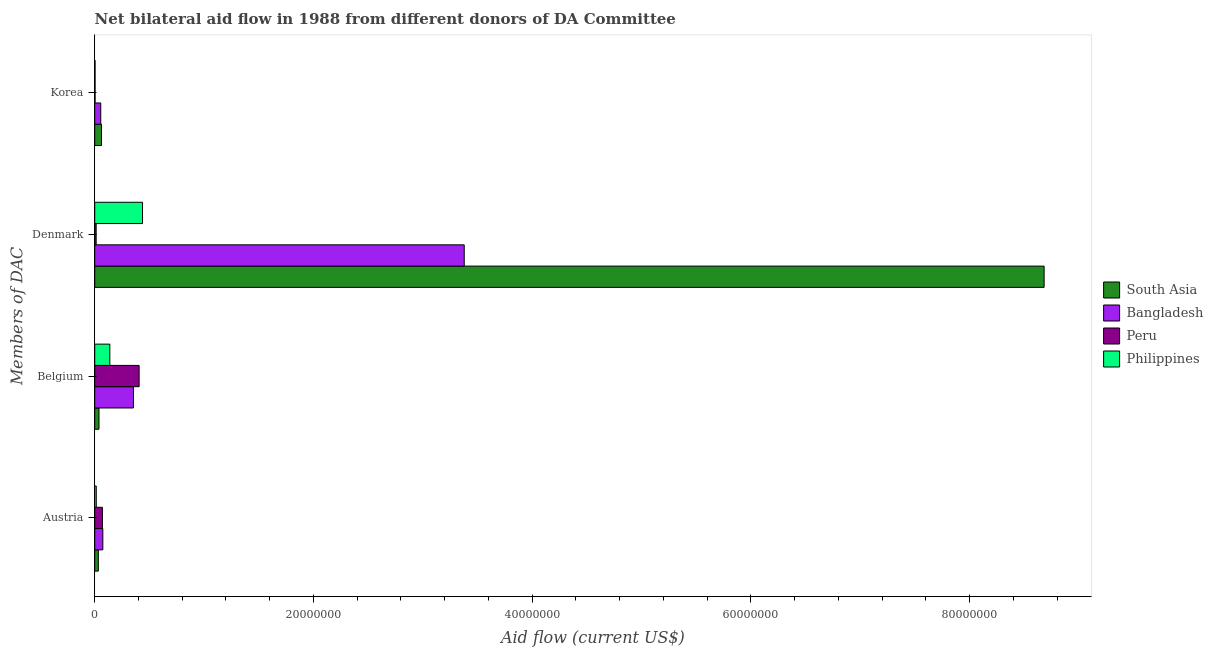Are the number of bars on each tick of the Y-axis equal?
Make the answer very short. Yes. How many bars are there on the 2nd tick from the bottom?
Ensure brevity in your answer.  4. What is the label of the 2nd group of bars from the top?
Make the answer very short. Denmark. What is the amount of aid given by korea in Philippines?
Keep it short and to the point. 3.00e+04. Across all countries, what is the maximum amount of aid given by korea?
Offer a terse response. 6.20e+05. Across all countries, what is the minimum amount of aid given by austria?
Offer a terse response. 1.40e+05. In which country was the amount of aid given by belgium maximum?
Offer a terse response. Peru. What is the total amount of aid given by belgium in the graph?
Your answer should be compact. 9.37e+06. What is the difference between the amount of aid given by austria in Bangladesh and that in Peru?
Make the answer very short. 4.00e+04. What is the difference between the amount of aid given by korea in South Asia and the amount of aid given by denmark in Philippines?
Provide a short and direct response. -3.75e+06. What is the average amount of aid given by austria per country?
Give a very brief answer. 4.78e+05. What is the difference between the amount of aid given by belgium and amount of aid given by denmark in Philippines?
Your answer should be compact. -2.99e+06. In how many countries, is the amount of aid given by austria greater than 36000000 US$?
Give a very brief answer. 0. What is the ratio of the amount of aid given by denmark in Peru to that in Philippines?
Give a very brief answer. 0.03. What is the difference between the highest and the second highest amount of aid given by belgium?
Offer a terse response. 5.20e+05. What is the difference between the highest and the lowest amount of aid given by korea?
Provide a short and direct response. 5.90e+05. In how many countries, is the amount of aid given by austria greater than the average amount of aid given by austria taken over all countries?
Keep it short and to the point. 2. What does the 3rd bar from the bottom in Denmark represents?
Your response must be concise. Peru. Are all the bars in the graph horizontal?
Keep it short and to the point. Yes. What is the difference between two consecutive major ticks on the X-axis?
Provide a short and direct response. 2.00e+07. Does the graph contain grids?
Give a very brief answer. No. Where does the legend appear in the graph?
Ensure brevity in your answer.  Center right. What is the title of the graph?
Your response must be concise. Net bilateral aid flow in 1988 from different donors of DA Committee. What is the label or title of the Y-axis?
Provide a short and direct response. Members of DAC. What is the Aid flow (current US$) in Bangladesh in Austria?
Keep it short and to the point. 7.40e+05. What is the Aid flow (current US$) of South Asia in Belgium?
Your answer should be very brief. 3.90e+05. What is the Aid flow (current US$) in Bangladesh in Belgium?
Offer a very short reply. 3.54e+06. What is the Aid flow (current US$) of Peru in Belgium?
Offer a terse response. 4.06e+06. What is the Aid flow (current US$) of Philippines in Belgium?
Keep it short and to the point. 1.38e+06. What is the Aid flow (current US$) in South Asia in Denmark?
Make the answer very short. 8.68e+07. What is the Aid flow (current US$) in Bangladesh in Denmark?
Keep it short and to the point. 3.38e+07. What is the Aid flow (current US$) of Peru in Denmark?
Give a very brief answer. 1.30e+05. What is the Aid flow (current US$) in Philippines in Denmark?
Provide a short and direct response. 4.37e+06. What is the Aid flow (current US$) of South Asia in Korea?
Keep it short and to the point. 6.20e+05. What is the Aid flow (current US$) in Bangladesh in Korea?
Provide a succinct answer. 5.50e+05. What is the Aid flow (current US$) in Peru in Korea?
Your response must be concise. 3.00e+04. What is the Aid flow (current US$) in Philippines in Korea?
Offer a terse response. 3.00e+04. Across all Members of DAC, what is the maximum Aid flow (current US$) of South Asia?
Provide a succinct answer. 8.68e+07. Across all Members of DAC, what is the maximum Aid flow (current US$) in Bangladesh?
Offer a very short reply. 3.38e+07. Across all Members of DAC, what is the maximum Aid flow (current US$) in Peru?
Give a very brief answer. 4.06e+06. Across all Members of DAC, what is the maximum Aid flow (current US$) in Philippines?
Offer a very short reply. 4.37e+06. Across all Members of DAC, what is the minimum Aid flow (current US$) in Bangladesh?
Your answer should be compact. 5.50e+05. Across all Members of DAC, what is the minimum Aid flow (current US$) of Peru?
Provide a short and direct response. 3.00e+04. What is the total Aid flow (current US$) of South Asia in the graph?
Your response must be concise. 8.82e+07. What is the total Aid flow (current US$) of Bangladesh in the graph?
Your answer should be very brief. 3.86e+07. What is the total Aid flow (current US$) of Peru in the graph?
Keep it short and to the point. 4.92e+06. What is the total Aid flow (current US$) of Philippines in the graph?
Provide a succinct answer. 5.92e+06. What is the difference between the Aid flow (current US$) in South Asia in Austria and that in Belgium?
Provide a short and direct response. -6.00e+04. What is the difference between the Aid flow (current US$) of Bangladesh in Austria and that in Belgium?
Your response must be concise. -2.80e+06. What is the difference between the Aid flow (current US$) of Peru in Austria and that in Belgium?
Keep it short and to the point. -3.36e+06. What is the difference between the Aid flow (current US$) of Philippines in Austria and that in Belgium?
Provide a short and direct response. -1.24e+06. What is the difference between the Aid flow (current US$) of South Asia in Austria and that in Denmark?
Provide a succinct answer. -8.65e+07. What is the difference between the Aid flow (current US$) of Bangladesh in Austria and that in Denmark?
Your answer should be compact. -3.30e+07. What is the difference between the Aid flow (current US$) of Peru in Austria and that in Denmark?
Your answer should be compact. 5.70e+05. What is the difference between the Aid flow (current US$) in Philippines in Austria and that in Denmark?
Make the answer very short. -4.23e+06. What is the difference between the Aid flow (current US$) in Bangladesh in Austria and that in Korea?
Your answer should be compact. 1.90e+05. What is the difference between the Aid flow (current US$) of Peru in Austria and that in Korea?
Provide a succinct answer. 6.70e+05. What is the difference between the Aid flow (current US$) of South Asia in Belgium and that in Denmark?
Offer a terse response. -8.64e+07. What is the difference between the Aid flow (current US$) in Bangladesh in Belgium and that in Denmark?
Offer a terse response. -3.02e+07. What is the difference between the Aid flow (current US$) in Peru in Belgium and that in Denmark?
Ensure brevity in your answer.  3.93e+06. What is the difference between the Aid flow (current US$) of Philippines in Belgium and that in Denmark?
Offer a very short reply. -2.99e+06. What is the difference between the Aid flow (current US$) of South Asia in Belgium and that in Korea?
Give a very brief answer. -2.30e+05. What is the difference between the Aid flow (current US$) of Bangladesh in Belgium and that in Korea?
Offer a terse response. 2.99e+06. What is the difference between the Aid flow (current US$) of Peru in Belgium and that in Korea?
Your answer should be compact. 4.03e+06. What is the difference between the Aid flow (current US$) in Philippines in Belgium and that in Korea?
Make the answer very short. 1.35e+06. What is the difference between the Aid flow (current US$) of South Asia in Denmark and that in Korea?
Your answer should be very brief. 8.62e+07. What is the difference between the Aid flow (current US$) of Bangladesh in Denmark and that in Korea?
Ensure brevity in your answer.  3.32e+07. What is the difference between the Aid flow (current US$) in Philippines in Denmark and that in Korea?
Provide a succinct answer. 4.34e+06. What is the difference between the Aid flow (current US$) of South Asia in Austria and the Aid flow (current US$) of Bangladesh in Belgium?
Your answer should be very brief. -3.21e+06. What is the difference between the Aid flow (current US$) in South Asia in Austria and the Aid flow (current US$) in Peru in Belgium?
Provide a short and direct response. -3.73e+06. What is the difference between the Aid flow (current US$) in South Asia in Austria and the Aid flow (current US$) in Philippines in Belgium?
Make the answer very short. -1.05e+06. What is the difference between the Aid flow (current US$) in Bangladesh in Austria and the Aid flow (current US$) in Peru in Belgium?
Your answer should be compact. -3.32e+06. What is the difference between the Aid flow (current US$) in Bangladesh in Austria and the Aid flow (current US$) in Philippines in Belgium?
Provide a succinct answer. -6.40e+05. What is the difference between the Aid flow (current US$) in Peru in Austria and the Aid flow (current US$) in Philippines in Belgium?
Offer a terse response. -6.80e+05. What is the difference between the Aid flow (current US$) of South Asia in Austria and the Aid flow (current US$) of Bangladesh in Denmark?
Keep it short and to the point. -3.35e+07. What is the difference between the Aid flow (current US$) in South Asia in Austria and the Aid flow (current US$) in Peru in Denmark?
Offer a very short reply. 2.00e+05. What is the difference between the Aid flow (current US$) of South Asia in Austria and the Aid flow (current US$) of Philippines in Denmark?
Offer a very short reply. -4.04e+06. What is the difference between the Aid flow (current US$) in Bangladesh in Austria and the Aid flow (current US$) in Philippines in Denmark?
Offer a terse response. -3.63e+06. What is the difference between the Aid flow (current US$) in Peru in Austria and the Aid flow (current US$) in Philippines in Denmark?
Your response must be concise. -3.67e+06. What is the difference between the Aid flow (current US$) in South Asia in Austria and the Aid flow (current US$) in Bangladesh in Korea?
Offer a very short reply. -2.20e+05. What is the difference between the Aid flow (current US$) of South Asia in Austria and the Aid flow (current US$) of Peru in Korea?
Your answer should be compact. 3.00e+05. What is the difference between the Aid flow (current US$) in Bangladesh in Austria and the Aid flow (current US$) in Peru in Korea?
Offer a terse response. 7.10e+05. What is the difference between the Aid flow (current US$) in Bangladesh in Austria and the Aid flow (current US$) in Philippines in Korea?
Provide a short and direct response. 7.10e+05. What is the difference between the Aid flow (current US$) of Peru in Austria and the Aid flow (current US$) of Philippines in Korea?
Provide a short and direct response. 6.70e+05. What is the difference between the Aid flow (current US$) in South Asia in Belgium and the Aid flow (current US$) in Bangladesh in Denmark?
Make the answer very short. -3.34e+07. What is the difference between the Aid flow (current US$) in South Asia in Belgium and the Aid flow (current US$) in Peru in Denmark?
Your response must be concise. 2.60e+05. What is the difference between the Aid flow (current US$) in South Asia in Belgium and the Aid flow (current US$) in Philippines in Denmark?
Provide a short and direct response. -3.98e+06. What is the difference between the Aid flow (current US$) in Bangladesh in Belgium and the Aid flow (current US$) in Peru in Denmark?
Offer a very short reply. 3.41e+06. What is the difference between the Aid flow (current US$) of Bangladesh in Belgium and the Aid flow (current US$) of Philippines in Denmark?
Make the answer very short. -8.30e+05. What is the difference between the Aid flow (current US$) of Peru in Belgium and the Aid flow (current US$) of Philippines in Denmark?
Provide a short and direct response. -3.10e+05. What is the difference between the Aid flow (current US$) of South Asia in Belgium and the Aid flow (current US$) of Bangladesh in Korea?
Offer a terse response. -1.60e+05. What is the difference between the Aid flow (current US$) in South Asia in Belgium and the Aid flow (current US$) in Peru in Korea?
Offer a terse response. 3.60e+05. What is the difference between the Aid flow (current US$) of South Asia in Belgium and the Aid flow (current US$) of Philippines in Korea?
Your response must be concise. 3.60e+05. What is the difference between the Aid flow (current US$) of Bangladesh in Belgium and the Aid flow (current US$) of Peru in Korea?
Keep it short and to the point. 3.51e+06. What is the difference between the Aid flow (current US$) in Bangladesh in Belgium and the Aid flow (current US$) in Philippines in Korea?
Your response must be concise. 3.51e+06. What is the difference between the Aid flow (current US$) of Peru in Belgium and the Aid flow (current US$) of Philippines in Korea?
Your answer should be very brief. 4.03e+06. What is the difference between the Aid flow (current US$) in South Asia in Denmark and the Aid flow (current US$) in Bangladesh in Korea?
Offer a terse response. 8.63e+07. What is the difference between the Aid flow (current US$) in South Asia in Denmark and the Aid flow (current US$) in Peru in Korea?
Offer a terse response. 8.68e+07. What is the difference between the Aid flow (current US$) in South Asia in Denmark and the Aid flow (current US$) in Philippines in Korea?
Make the answer very short. 8.68e+07. What is the difference between the Aid flow (current US$) of Bangladesh in Denmark and the Aid flow (current US$) of Peru in Korea?
Your response must be concise. 3.38e+07. What is the difference between the Aid flow (current US$) in Bangladesh in Denmark and the Aid flow (current US$) in Philippines in Korea?
Your answer should be very brief. 3.38e+07. What is the difference between the Aid flow (current US$) of Peru in Denmark and the Aid flow (current US$) of Philippines in Korea?
Keep it short and to the point. 1.00e+05. What is the average Aid flow (current US$) of South Asia per Members of DAC?
Ensure brevity in your answer.  2.20e+07. What is the average Aid flow (current US$) in Bangladesh per Members of DAC?
Provide a succinct answer. 9.66e+06. What is the average Aid flow (current US$) of Peru per Members of DAC?
Your response must be concise. 1.23e+06. What is the average Aid flow (current US$) in Philippines per Members of DAC?
Your answer should be very brief. 1.48e+06. What is the difference between the Aid flow (current US$) in South Asia and Aid flow (current US$) in Bangladesh in Austria?
Provide a short and direct response. -4.10e+05. What is the difference between the Aid flow (current US$) in South Asia and Aid flow (current US$) in Peru in Austria?
Provide a succinct answer. -3.70e+05. What is the difference between the Aid flow (current US$) of South Asia and Aid flow (current US$) of Philippines in Austria?
Provide a short and direct response. 1.90e+05. What is the difference between the Aid flow (current US$) in Bangladesh and Aid flow (current US$) in Peru in Austria?
Provide a short and direct response. 4.00e+04. What is the difference between the Aid flow (current US$) in Bangladesh and Aid flow (current US$) in Philippines in Austria?
Ensure brevity in your answer.  6.00e+05. What is the difference between the Aid flow (current US$) of Peru and Aid flow (current US$) of Philippines in Austria?
Keep it short and to the point. 5.60e+05. What is the difference between the Aid flow (current US$) of South Asia and Aid flow (current US$) of Bangladesh in Belgium?
Keep it short and to the point. -3.15e+06. What is the difference between the Aid flow (current US$) of South Asia and Aid flow (current US$) of Peru in Belgium?
Provide a succinct answer. -3.67e+06. What is the difference between the Aid flow (current US$) of South Asia and Aid flow (current US$) of Philippines in Belgium?
Your answer should be very brief. -9.90e+05. What is the difference between the Aid flow (current US$) of Bangladesh and Aid flow (current US$) of Peru in Belgium?
Provide a short and direct response. -5.20e+05. What is the difference between the Aid flow (current US$) in Bangladesh and Aid flow (current US$) in Philippines in Belgium?
Offer a terse response. 2.16e+06. What is the difference between the Aid flow (current US$) of Peru and Aid flow (current US$) of Philippines in Belgium?
Provide a succinct answer. 2.68e+06. What is the difference between the Aid flow (current US$) of South Asia and Aid flow (current US$) of Bangladesh in Denmark?
Ensure brevity in your answer.  5.30e+07. What is the difference between the Aid flow (current US$) in South Asia and Aid flow (current US$) in Peru in Denmark?
Your response must be concise. 8.67e+07. What is the difference between the Aid flow (current US$) in South Asia and Aid flow (current US$) in Philippines in Denmark?
Provide a succinct answer. 8.24e+07. What is the difference between the Aid flow (current US$) of Bangladesh and Aid flow (current US$) of Peru in Denmark?
Give a very brief answer. 3.37e+07. What is the difference between the Aid flow (current US$) in Bangladesh and Aid flow (current US$) in Philippines in Denmark?
Ensure brevity in your answer.  2.94e+07. What is the difference between the Aid flow (current US$) in Peru and Aid flow (current US$) in Philippines in Denmark?
Provide a succinct answer. -4.24e+06. What is the difference between the Aid flow (current US$) of South Asia and Aid flow (current US$) of Bangladesh in Korea?
Offer a terse response. 7.00e+04. What is the difference between the Aid flow (current US$) of South Asia and Aid flow (current US$) of Peru in Korea?
Provide a short and direct response. 5.90e+05. What is the difference between the Aid flow (current US$) of South Asia and Aid flow (current US$) of Philippines in Korea?
Offer a very short reply. 5.90e+05. What is the difference between the Aid flow (current US$) in Bangladesh and Aid flow (current US$) in Peru in Korea?
Keep it short and to the point. 5.20e+05. What is the difference between the Aid flow (current US$) in Bangladesh and Aid flow (current US$) in Philippines in Korea?
Your answer should be compact. 5.20e+05. What is the ratio of the Aid flow (current US$) of South Asia in Austria to that in Belgium?
Offer a very short reply. 0.85. What is the ratio of the Aid flow (current US$) in Bangladesh in Austria to that in Belgium?
Offer a very short reply. 0.21. What is the ratio of the Aid flow (current US$) of Peru in Austria to that in Belgium?
Your response must be concise. 0.17. What is the ratio of the Aid flow (current US$) in Philippines in Austria to that in Belgium?
Provide a succinct answer. 0.1. What is the ratio of the Aid flow (current US$) of South Asia in Austria to that in Denmark?
Your response must be concise. 0. What is the ratio of the Aid flow (current US$) in Bangladesh in Austria to that in Denmark?
Give a very brief answer. 0.02. What is the ratio of the Aid flow (current US$) of Peru in Austria to that in Denmark?
Provide a short and direct response. 5.38. What is the ratio of the Aid flow (current US$) of Philippines in Austria to that in Denmark?
Your answer should be very brief. 0.03. What is the ratio of the Aid flow (current US$) in South Asia in Austria to that in Korea?
Offer a terse response. 0.53. What is the ratio of the Aid flow (current US$) of Bangladesh in Austria to that in Korea?
Provide a short and direct response. 1.35. What is the ratio of the Aid flow (current US$) in Peru in Austria to that in Korea?
Your response must be concise. 23.33. What is the ratio of the Aid flow (current US$) in Philippines in Austria to that in Korea?
Your answer should be very brief. 4.67. What is the ratio of the Aid flow (current US$) of South Asia in Belgium to that in Denmark?
Offer a very short reply. 0. What is the ratio of the Aid flow (current US$) in Bangladesh in Belgium to that in Denmark?
Provide a succinct answer. 0.1. What is the ratio of the Aid flow (current US$) of Peru in Belgium to that in Denmark?
Offer a very short reply. 31.23. What is the ratio of the Aid flow (current US$) of Philippines in Belgium to that in Denmark?
Offer a terse response. 0.32. What is the ratio of the Aid flow (current US$) in South Asia in Belgium to that in Korea?
Offer a very short reply. 0.63. What is the ratio of the Aid flow (current US$) in Bangladesh in Belgium to that in Korea?
Your answer should be compact. 6.44. What is the ratio of the Aid flow (current US$) in Peru in Belgium to that in Korea?
Your response must be concise. 135.33. What is the ratio of the Aid flow (current US$) in Philippines in Belgium to that in Korea?
Make the answer very short. 46. What is the ratio of the Aid flow (current US$) of South Asia in Denmark to that in Korea?
Your answer should be compact. 140.03. What is the ratio of the Aid flow (current US$) in Bangladesh in Denmark to that in Korea?
Your answer should be very brief. 61.44. What is the ratio of the Aid flow (current US$) in Peru in Denmark to that in Korea?
Your answer should be compact. 4.33. What is the ratio of the Aid flow (current US$) in Philippines in Denmark to that in Korea?
Make the answer very short. 145.67. What is the difference between the highest and the second highest Aid flow (current US$) in South Asia?
Provide a succinct answer. 8.62e+07. What is the difference between the highest and the second highest Aid flow (current US$) of Bangladesh?
Your response must be concise. 3.02e+07. What is the difference between the highest and the second highest Aid flow (current US$) of Peru?
Ensure brevity in your answer.  3.36e+06. What is the difference between the highest and the second highest Aid flow (current US$) in Philippines?
Ensure brevity in your answer.  2.99e+06. What is the difference between the highest and the lowest Aid flow (current US$) in South Asia?
Keep it short and to the point. 8.65e+07. What is the difference between the highest and the lowest Aid flow (current US$) of Bangladesh?
Keep it short and to the point. 3.32e+07. What is the difference between the highest and the lowest Aid flow (current US$) in Peru?
Provide a short and direct response. 4.03e+06. What is the difference between the highest and the lowest Aid flow (current US$) of Philippines?
Make the answer very short. 4.34e+06. 